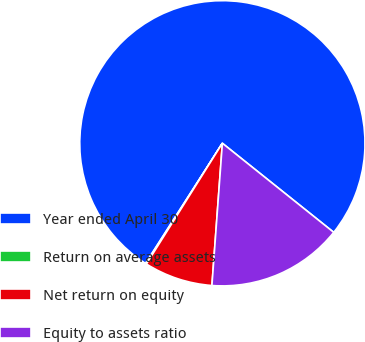<chart> <loc_0><loc_0><loc_500><loc_500><pie_chart><fcel>Year ended April 30<fcel>Return on average assets<fcel>Net return on equity<fcel>Equity to assets ratio<nl><fcel>76.69%<fcel>0.11%<fcel>7.77%<fcel>15.43%<nl></chart> 